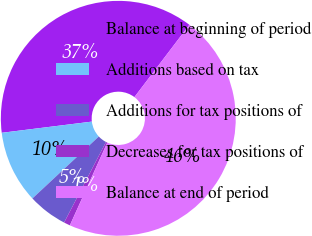Convert chart to OTSL. <chart><loc_0><loc_0><loc_500><loc_500><pie_chart><fcel>Balance at beginning of period<fcel>Additions based on tax<fcel>Additions for tax positions of<fcel>Decreases for tax positions of<fcel>Balance at end of period<nl><fcel>37.31%<fcel>9.98%<fcel>5.42%<fcel>0.87%<fcel>46.42%<nl></chart> 